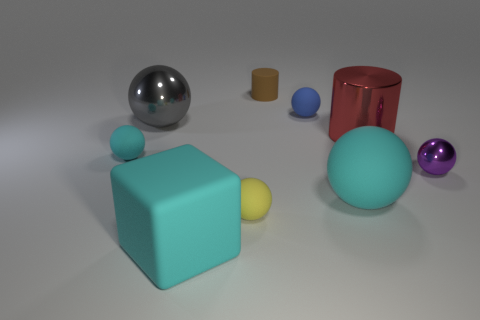Subtract 4 balls. How many balls are left? 2 Subtract all large gray metallic spheres. How many spheres are left? 5 Subtract all purple spheres. How many spheres are left? 5 Subtract all blue balls. Subtract all green cylinders. How many balls are left? 5 Subtract all blocks. How many objects are left? 8 Add 8 small blue rubber things. How many small blue rubber things exist? 9 Subtract 0 blue cylinders. How many objects are left? 9 Subtract all tiny purple matte blocks. Subtract all purple metal things. How many objects are left? 8 Add 4 gray shiny spheres. How many gray shiny spheres are left? 5 